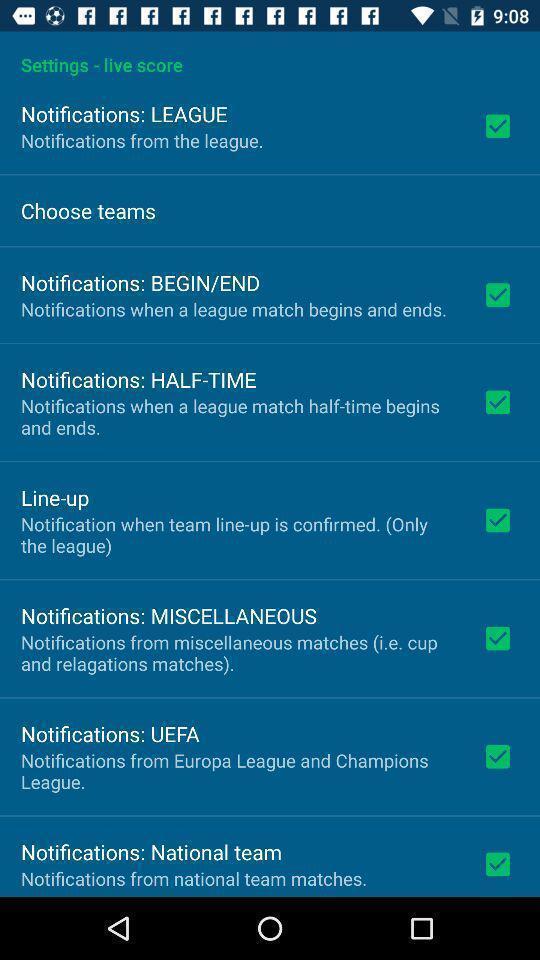What can you discern from this picture? Settings page. 